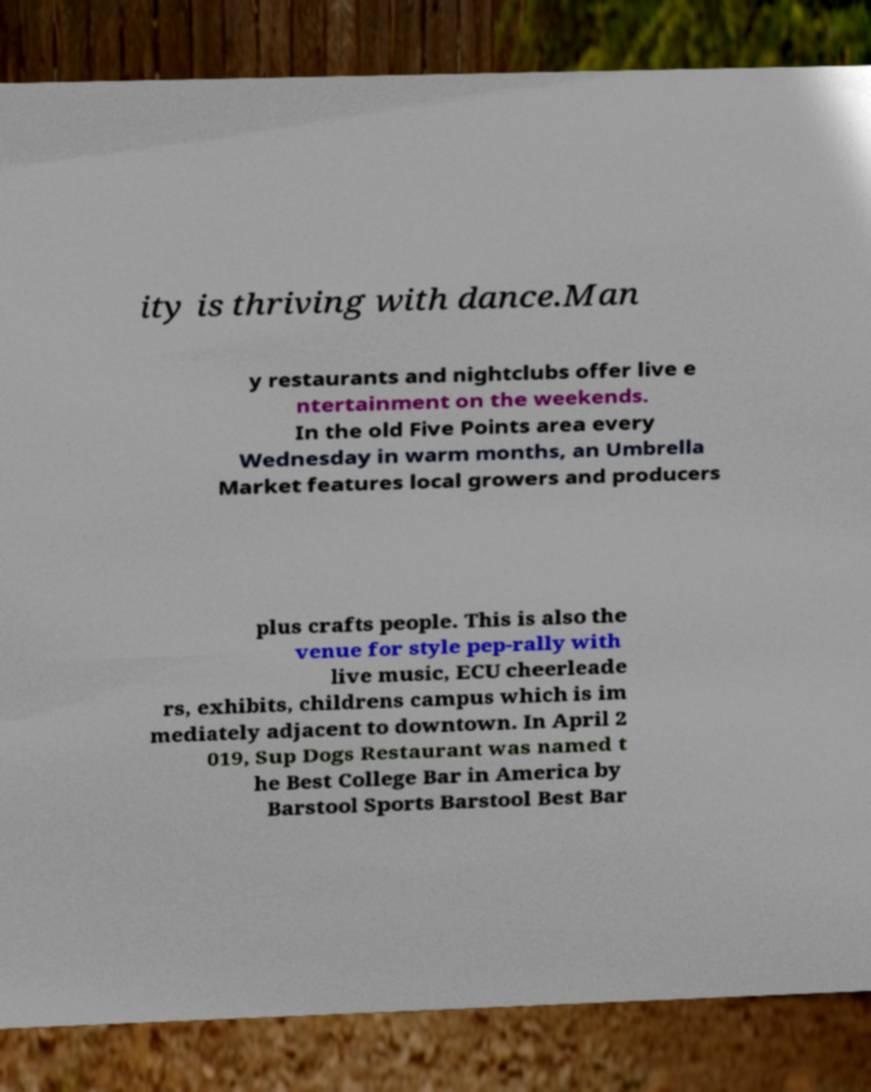Please read and relay the text visible in this image. What does it say? ity is thriving with dance.Man y restaurants and nightclubs offer live e ntertainment on the weekends. In the old Five Points area every Wednesday in warm months, an Umbrella Market features local growers and producers plus crafts people. This is also the venue for style pep-rally with live music, ECU cheerleade rs, exhibits, childrens campus which is im mediately adjacent to downtown. In April 2 019, Sup Dogs Restaurant was named t he Best College Bar in America by Barstool Sports Barstool Best Bar 